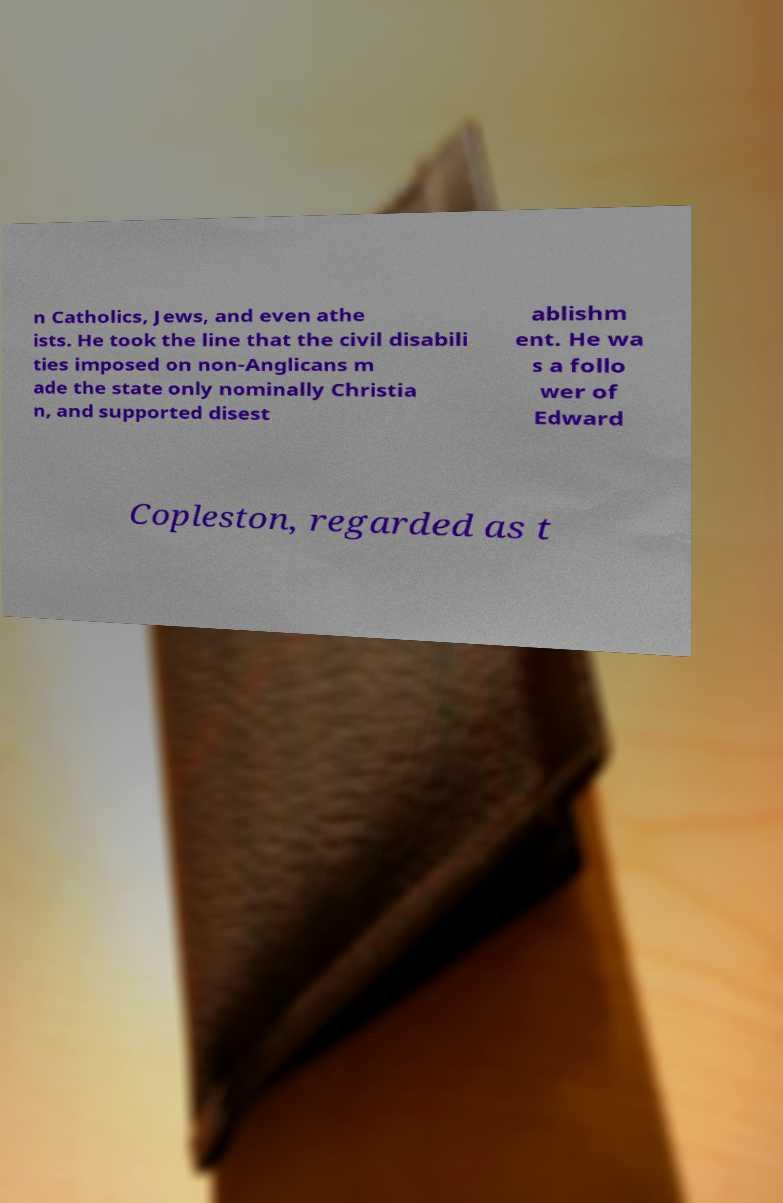I need the written content from this picture converted into text. Can you do that? n Catholics, Jews, and even athe ists. He took the line that the civil disabili ties imposed on non-Anglicans m ade the state only nominally Christia n, and supported disest ablishm ent. He wa s a follo wer of Edward Copleston, regarded as t 